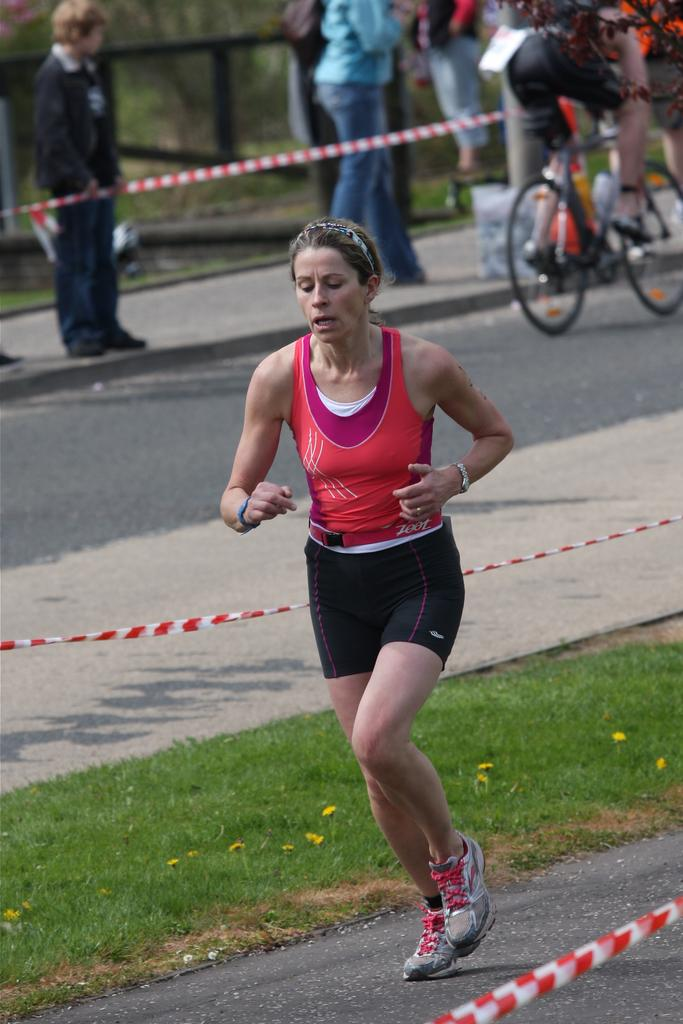Where was the image taken? The image was clicked outside. What can be seen at the top of the image? There is a cycle and people standing at the top of the image. What is happening in the middle of the image? There is a person running in the middle of the image. Where is the mitten located in the image? There is no mitten present in the image. How many sheep can be seen in the image? There are no sheep present in the image. 